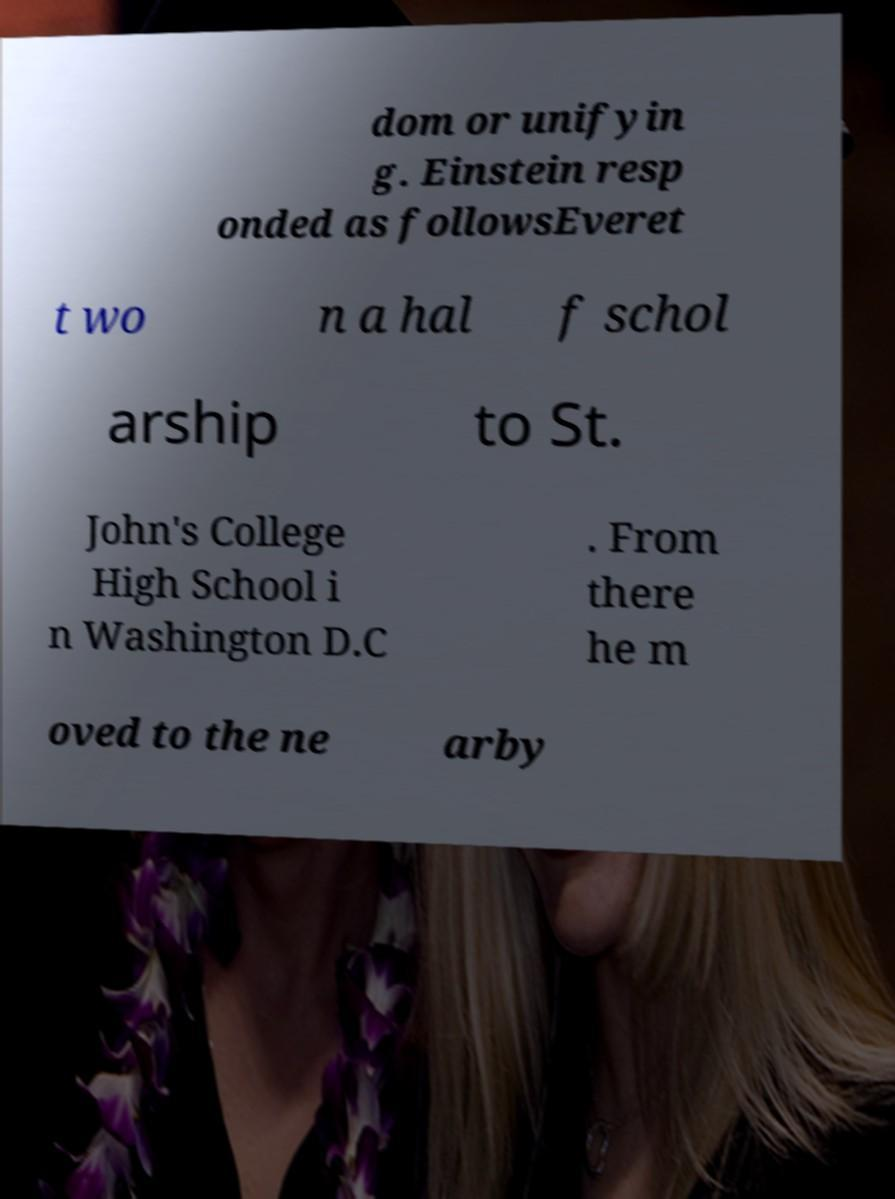For documentation purposes, I need the text within this image transcribed. Could you provide that? dom or unifyin g. Einstein resp onded as followsEveret t wo n a hal f schol arship to St. John's College High School i n Washington D.C . From there he m oved to the ne arby 